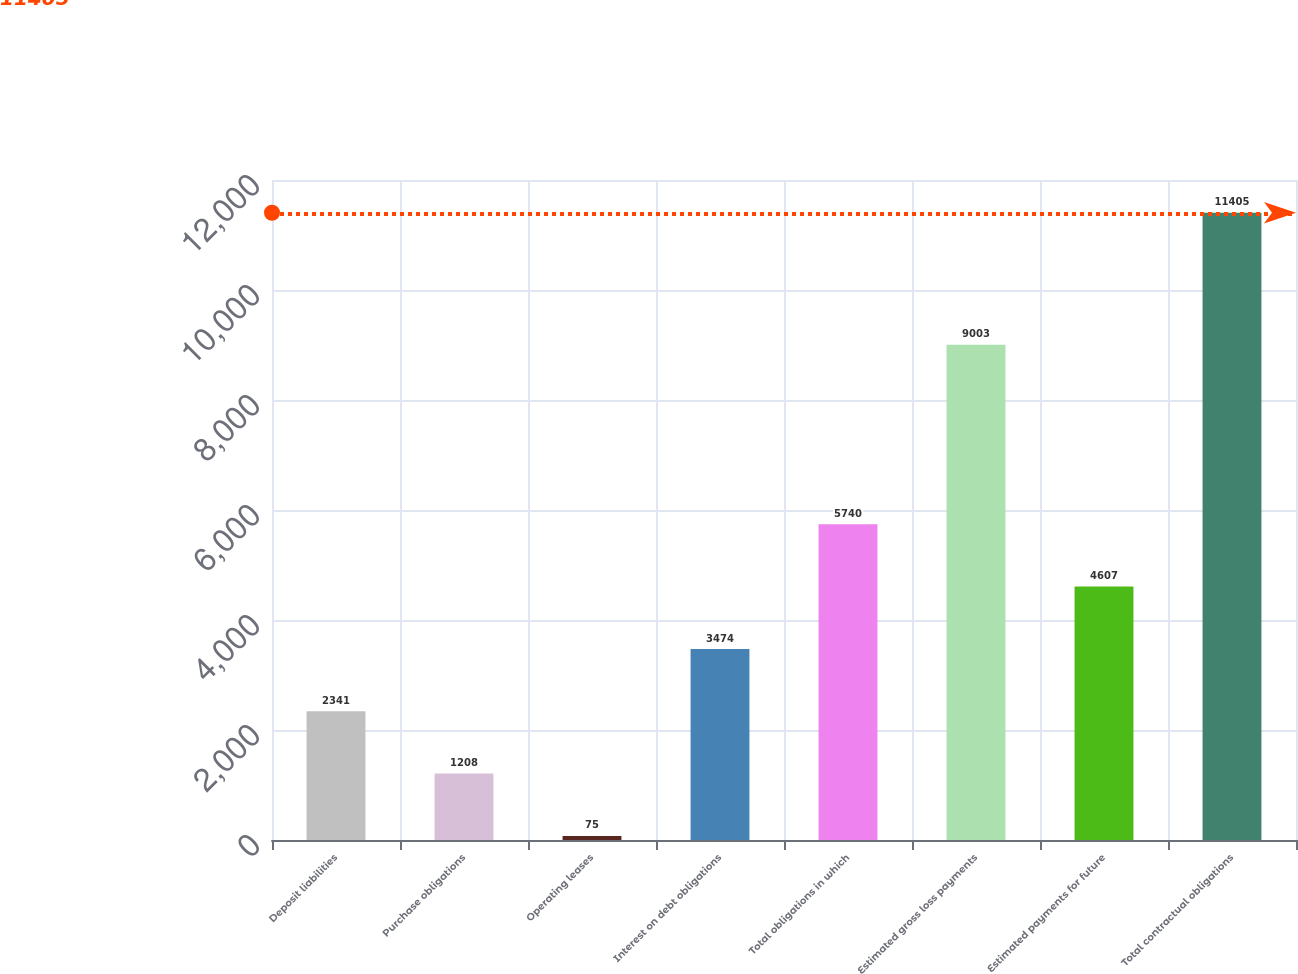Convert chart to OTSL. <chart><loc_0><loc_0><loc_500><loc_500><bar_chart><fcel>Deposit liabilities<fcel>Purchase obligations<fcel>Operating leases<fcel>Interest on debt obligations<fcel>Total obligations in which<fcel>Estimated gross loss payments<fcel>Estimated payments for future<fcel>Total contractual obligations<nl><fcel>2341<fcel>1208<fcel>75<fcel>3474<fcel>5740<fcel>9003<fcel>4607<fcel>11405<nl></chart> 